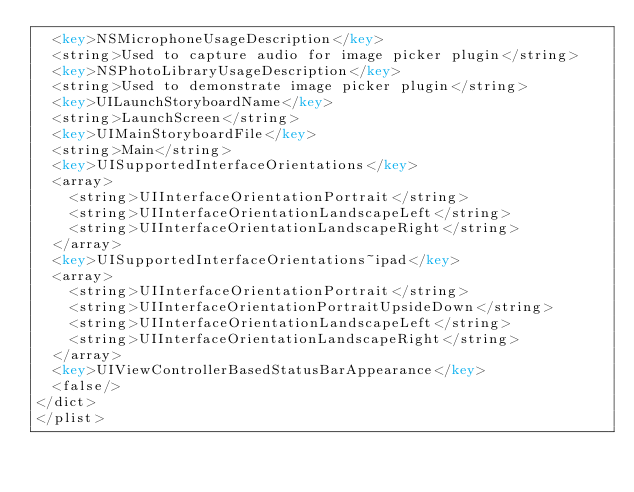<code> <loc_0><loc_0><loc_500><loc_500><_XML_>	<key>NSMicrophoneUsageDescription</key>
	<string>Used to capture audio for image picker plugin</string>
	<key>NSPhotoLibraryUsageDescription</key>
	<string>Used to demonstrate image picker plugin</string>
	<key>UILaunchStoryboardName</key>
	<string>LaunchScreen</string>
	<key>UIMainStoryboardFile</key>
	<string>Main</string>
	<key>UISupportedInterfaceOrientations</key>
	<array>
		<string>UIInterfaceOrientationPortrait</string>
		<string>UIInterfaceOrientationLandscapeLeft</string>
		<string>UIInterfaceOrientationLandscapeRight</string>
	</array>
	<key>UISupportedInterfaceOrientations~ipad</key>
	<array>
		<string>UIInterfaceOrientationPortrait</string>
		<string>UIInterfaceOrientationPortraitUpsideDown</string>
		<string>UIInterfaceOrientationLandscapeLeft</string>
		<string>UIInterfaceOrientationLandscapeRight</string>
	</array>
	<key>UIViewControllerBasedStatusBarAppearance</key>
	<false/>
</dict>
</plist>
</code> 